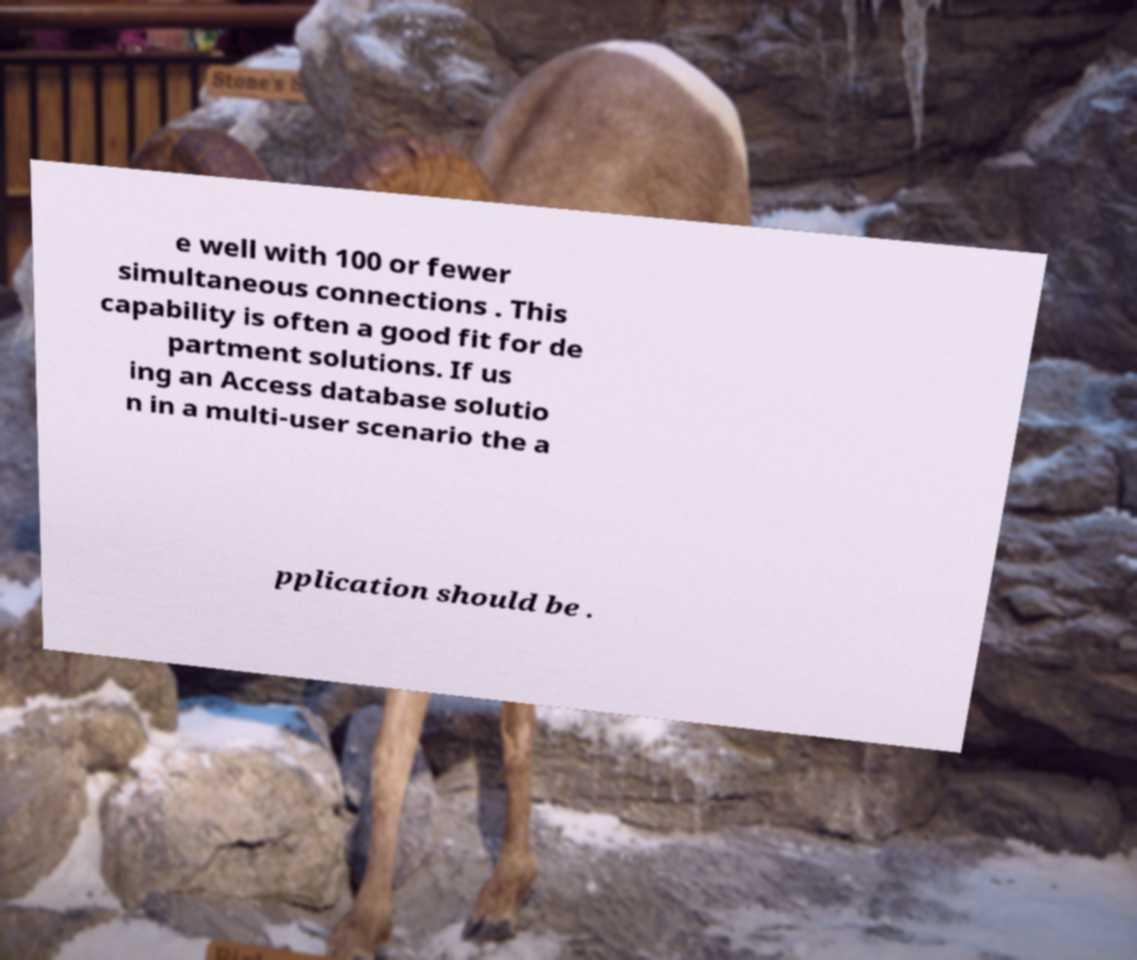For documentation purposes, I need the text within this image transcribed. Could you provide that? e well with 100 or fewer simultaneous connections . This capability is often a good fit for de partment solutions. If us ing an Access database solutio n in a multi-user scenario the a pplication should be . 